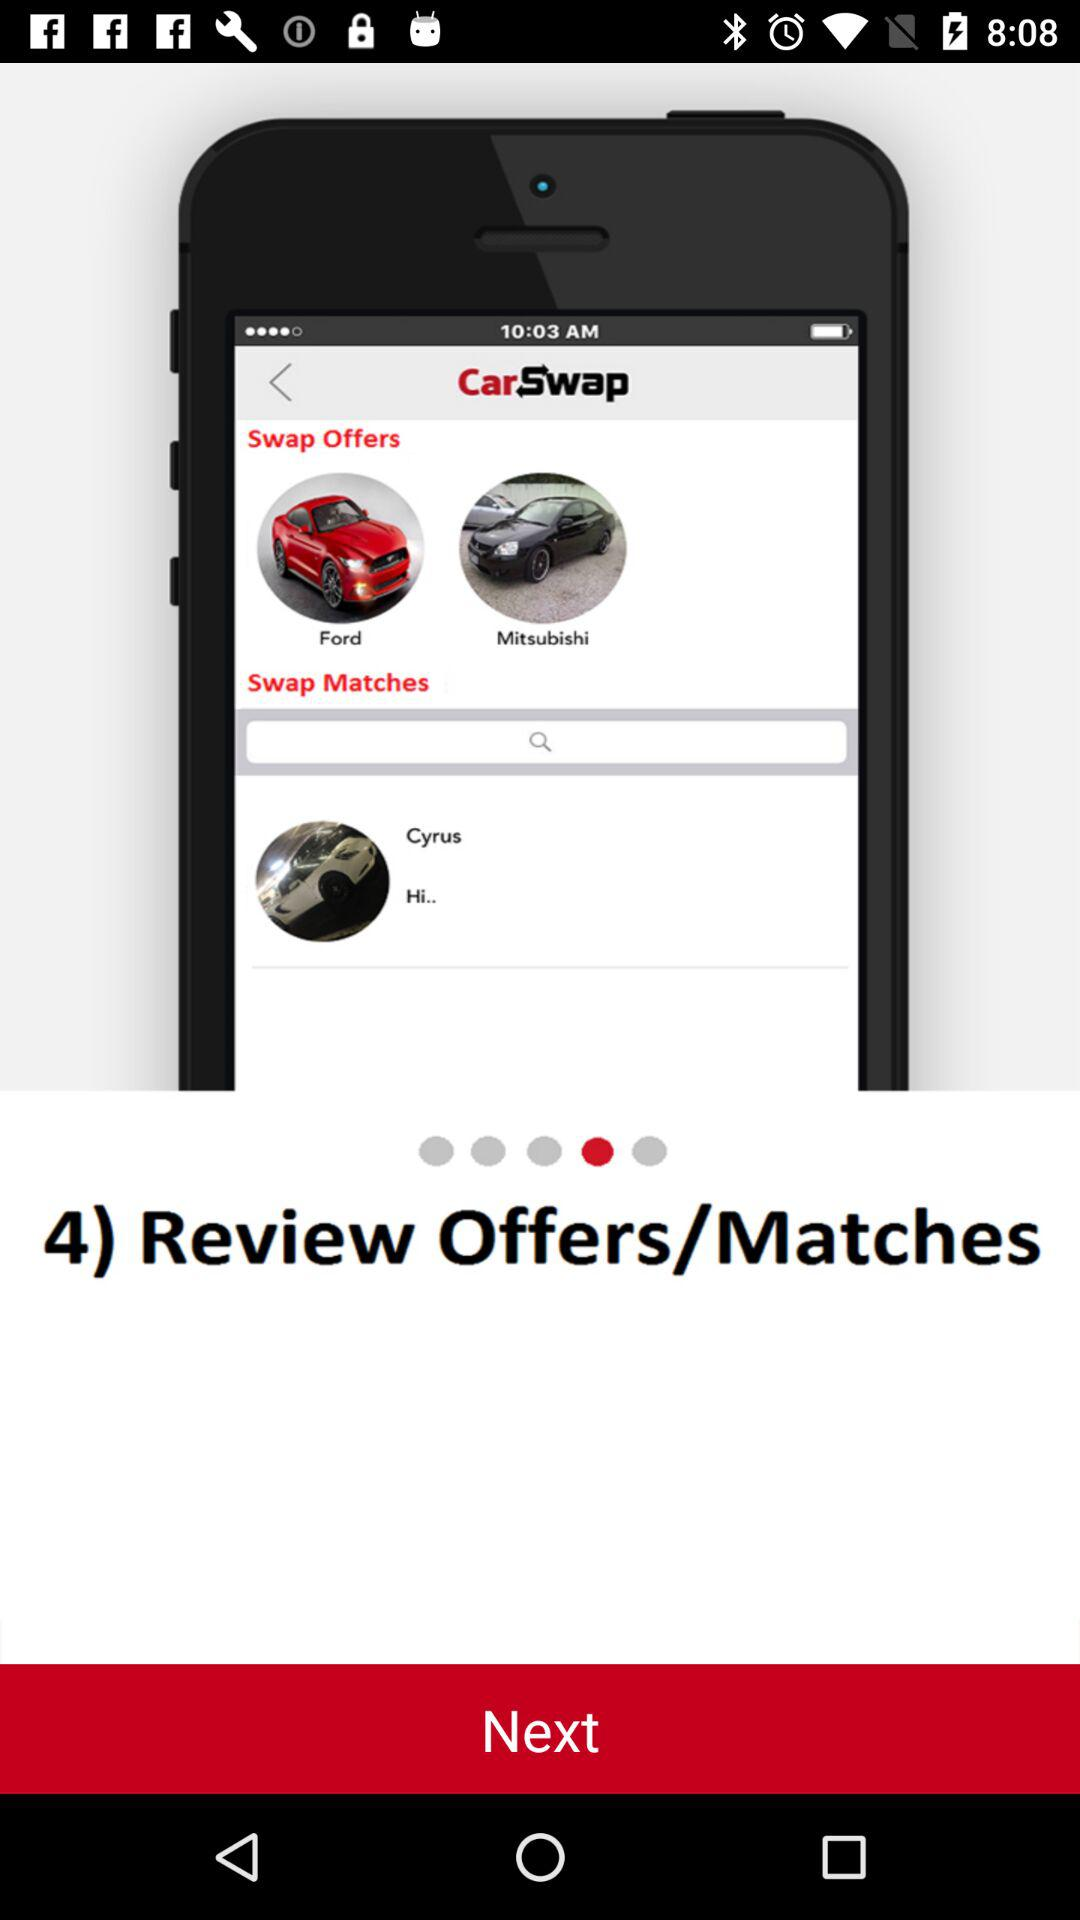Which type of Ford vehicles are available?
When the provided information is insufficient, respond with <no answer>. <no answer> 